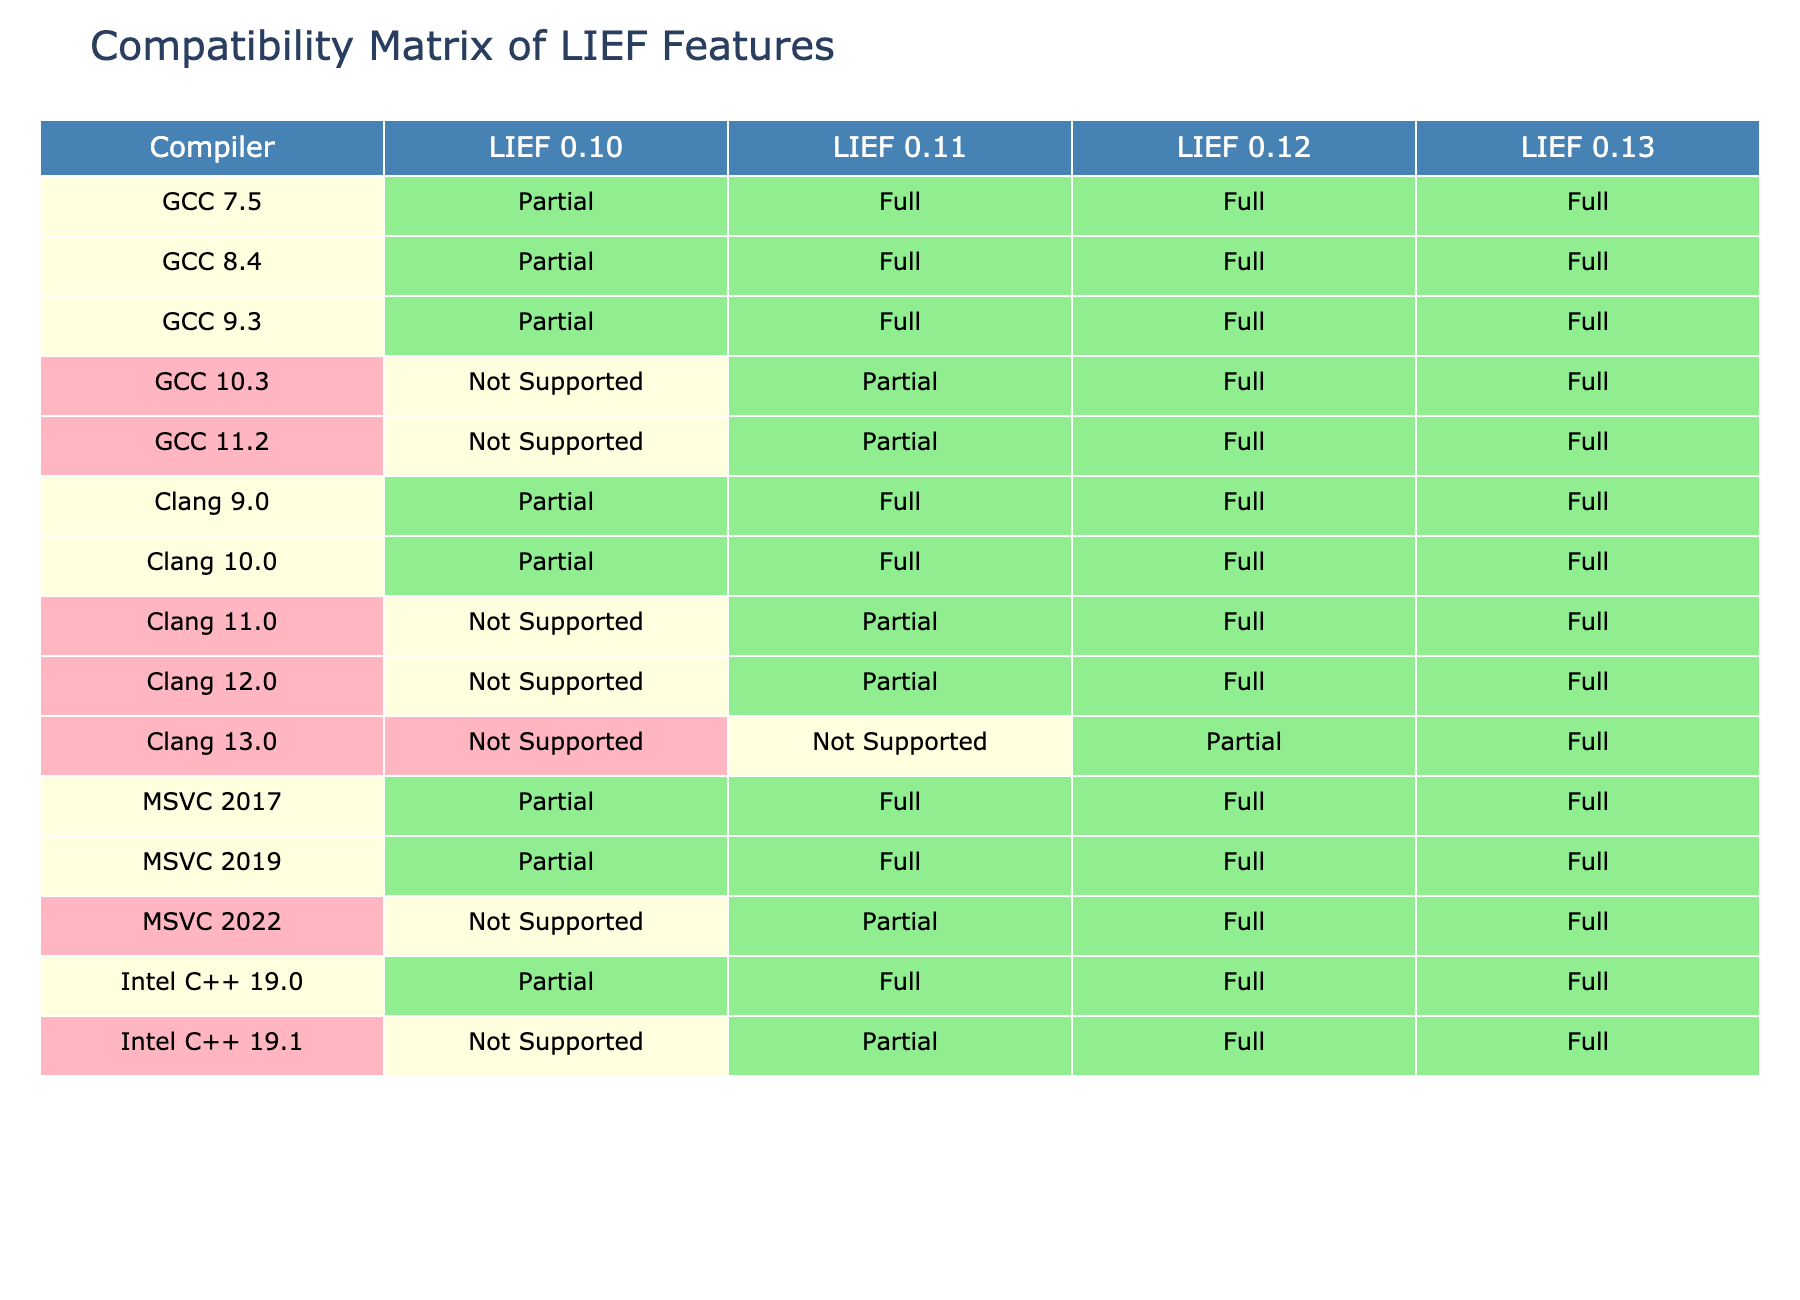What is the compatibility level of GCC 9.3 with LIEF version 0.10? By referring to the row for GCC 9.3 in the table and the column for LIEF 0.10, the compatibility level is listed as "Partial."
Answer: Partial Which compiler has the best compatibility with LIEF version 0.13? Looking through the entire column for LIEF 0.13, the compilers that have "Full" compatibility are GCC 7.5, GCC 8.4, GCC 9.3, GCC 10.3, GCC 11.2, Clang 9.0, Clang 10.0, Clang 11.0, Clang 12.0, Clang 13.0, MSVC 2017, MSVC 2019, and MSVC 2022. Therefore, multiple compilers have the same level of compatibility.
Answer: Multiple compilers What is the total number of compilers that have "Not Supported" compatibility with LIEF version 0.12? By counting the occurrences of "Not Supported" in the column for LIEF 0.12, we find that there are 3 compilers (GCC 10.3, Clang 11.0, Clang 13.0, and Intel C++ 19.1) listed as "Not Supported."
Answer: 4 Is MSVC 2022 compatible with LIEF version 0.11? Referring to the table, the cell for MSVC 2022 under LIEF 0.11 shows "Partial," indicating that it is not fully compatible but not entirely unsupported either.
Answer: No Which compiler shows a transition from "Full" in LIEF version 0.11 to "Partial" in LIEF version 0.12? Checking the table, we can see that the Intel C++ 19.0 compiler has "Full" compatibility in LIEF 0.11 and then "Partial" compatibility in LIEF 0.12.
Answer: Intel C++ 19.0 How many compilers have "Full" support for all four LIEF versions listed? To find out, we check each row for the number of compilers that have "Full" for LIEF versions 0.10, 0.11, 0.12, and 0.13. From the data, we see that no compiler has "Full" support across all four versions.
Answer: 0 Which compiler moves from "Not Supported" in LIEF version 0.10 to "Full" in version 0.12? From the table, we can see that Clang 13.0 transitions from "Not Supported" in LIEF 0.10 to "Partial" in 0.11, and then to "Full" in 0.12. However, this is incorrect as there's no direct transition to "Full." Thus no such compiler exists.
Answer: No such compiler What is the compatibility of Intel C++ 19.1 with LIEF 0.12? According to the table in the Intel C++ 19.1 row, it lists "Full" for LIEF 0.12.
Answer: Full Which compiler has the least compatibility across the LIEF versions shown? By analyzing the table, the compiler "Clang 13.0" has "Not Supported" for LIEF 0.10 and 0.11, indicating it has the least overall compatibility.
Answer: Clang 13.0 